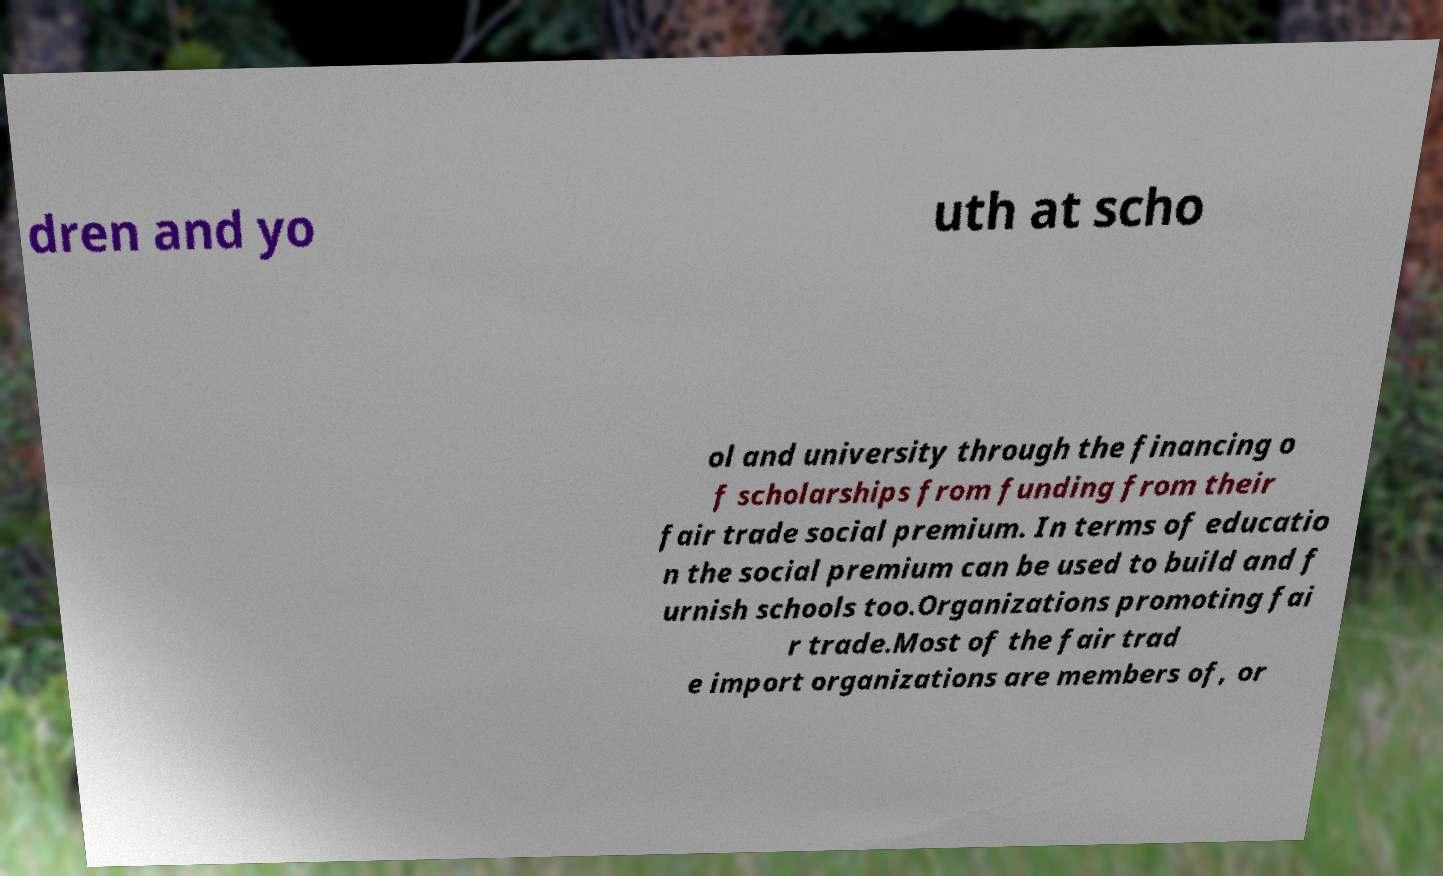Can you read and provide the text displayed in the image?This photo seems to have some interesting text. Can you extract and type it out for me? dren and yo uth at scho ol and university through the financing o f scholarships from funding from their fair trade social premium. In terms of educatio n the social premium can be used to build and f urnish schools too.Organizations promoting fai r trade.Most of the fair trad e import organizations are members of, or 